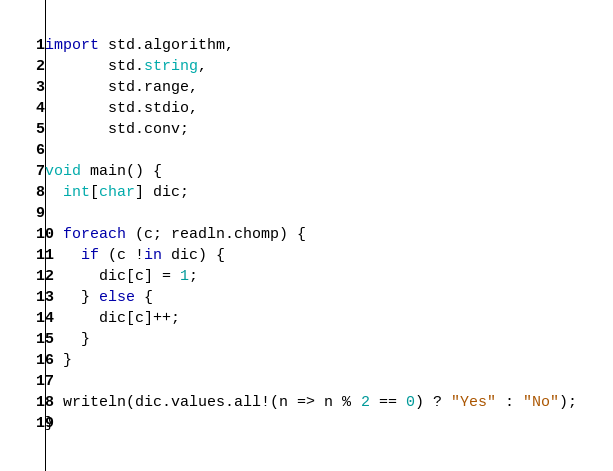Convert code to text. <code><loc_0><loc_0><loc_500><loc_500><_D_>import std.algorithm,
       std.string,
       std.range,
       std.stdio,
       std.conv;

void main() {
  int[char] dic;

  foreach (c; readln.chomp) {
    if (c !in dic) {
      dic[c] = 1;
    } else {
      dic[c]++;
    }
  }

  writeln(dic.values.all!(n => n % 2 == 0) ? "Yes" : "No");
}</code> 